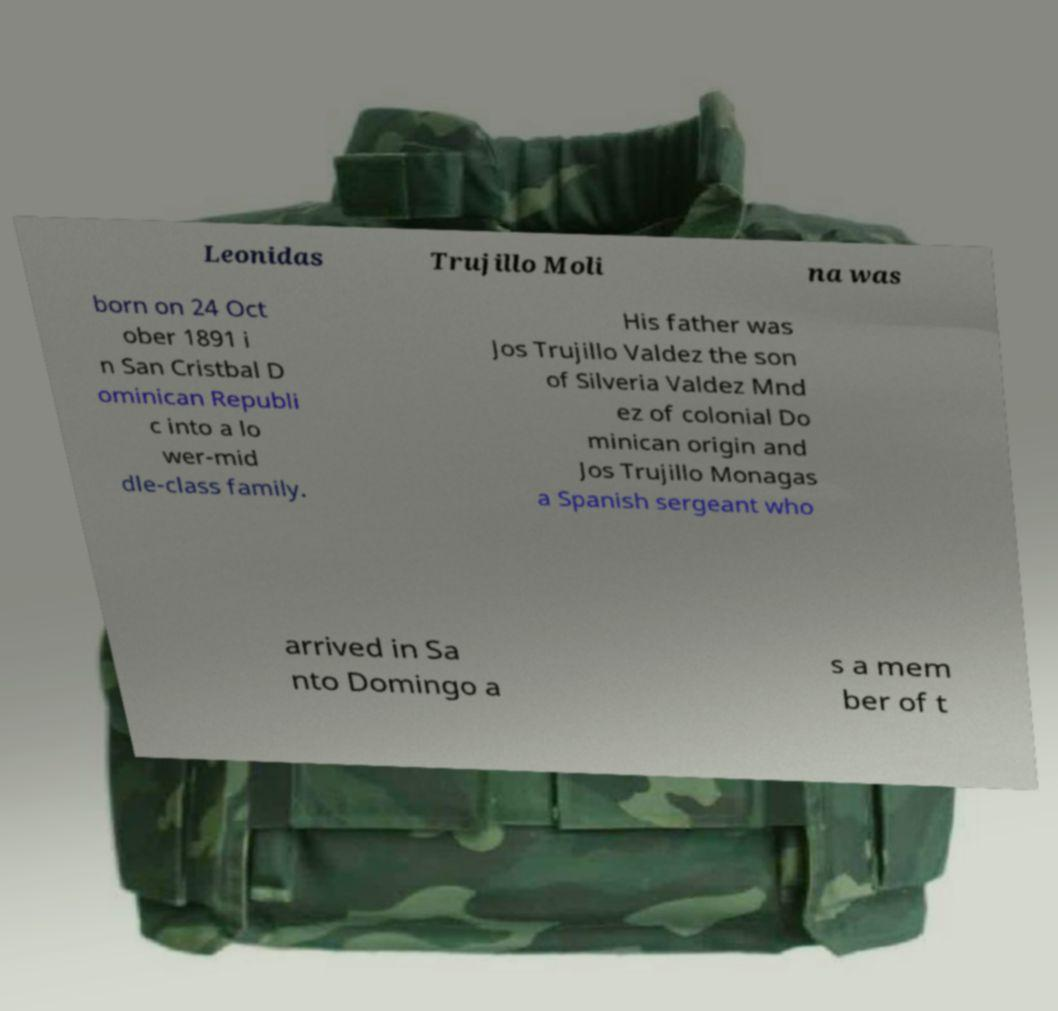Can you read and provide the text displayed in the image?This photo seems to have some interesting text. Can you extract and type it out for me? Leonidas Trujillo Moli na was born on 24 Oct ober 1891 i n San Cristbal D ominican Republi c into a lo wer-mid dle-class family. His father was Jos Trujillo Valdez the son of Silveria Valdez Mnd ez of colonial Do minican origin and Jos Trujillo Monagas a Spanish sergeant who arrived in Sa nto Domingo a s a mem ber of t 